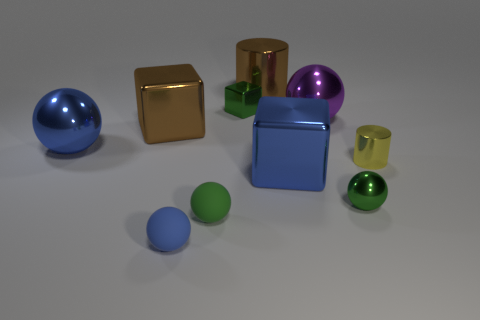Subtract all big blue metallic blocks. How many blocks are left? 2 Subtract all yellow cylinders. How many cylinders are left? 1 Subtract all brown cylinders. How many blue balls are left? 2 Subtract all blocks. How many objects are left? 7 Subtract 1 cylinders. How many cylinders are left? 1 Subtract all shiny blocks. Subtract all brown metal things. How many objects are left? 5 Add 3 tiny shiny cubes. How many tiny shiny cubes are left? 4 Add 9 blue metallic spheres. How many blue metallic spheres exist? 10 Subtract 0 red spheres. How many objects are left? 10 Subtract all red blocks. Subtract all yellow cylinders. How many blocks are left? 3 